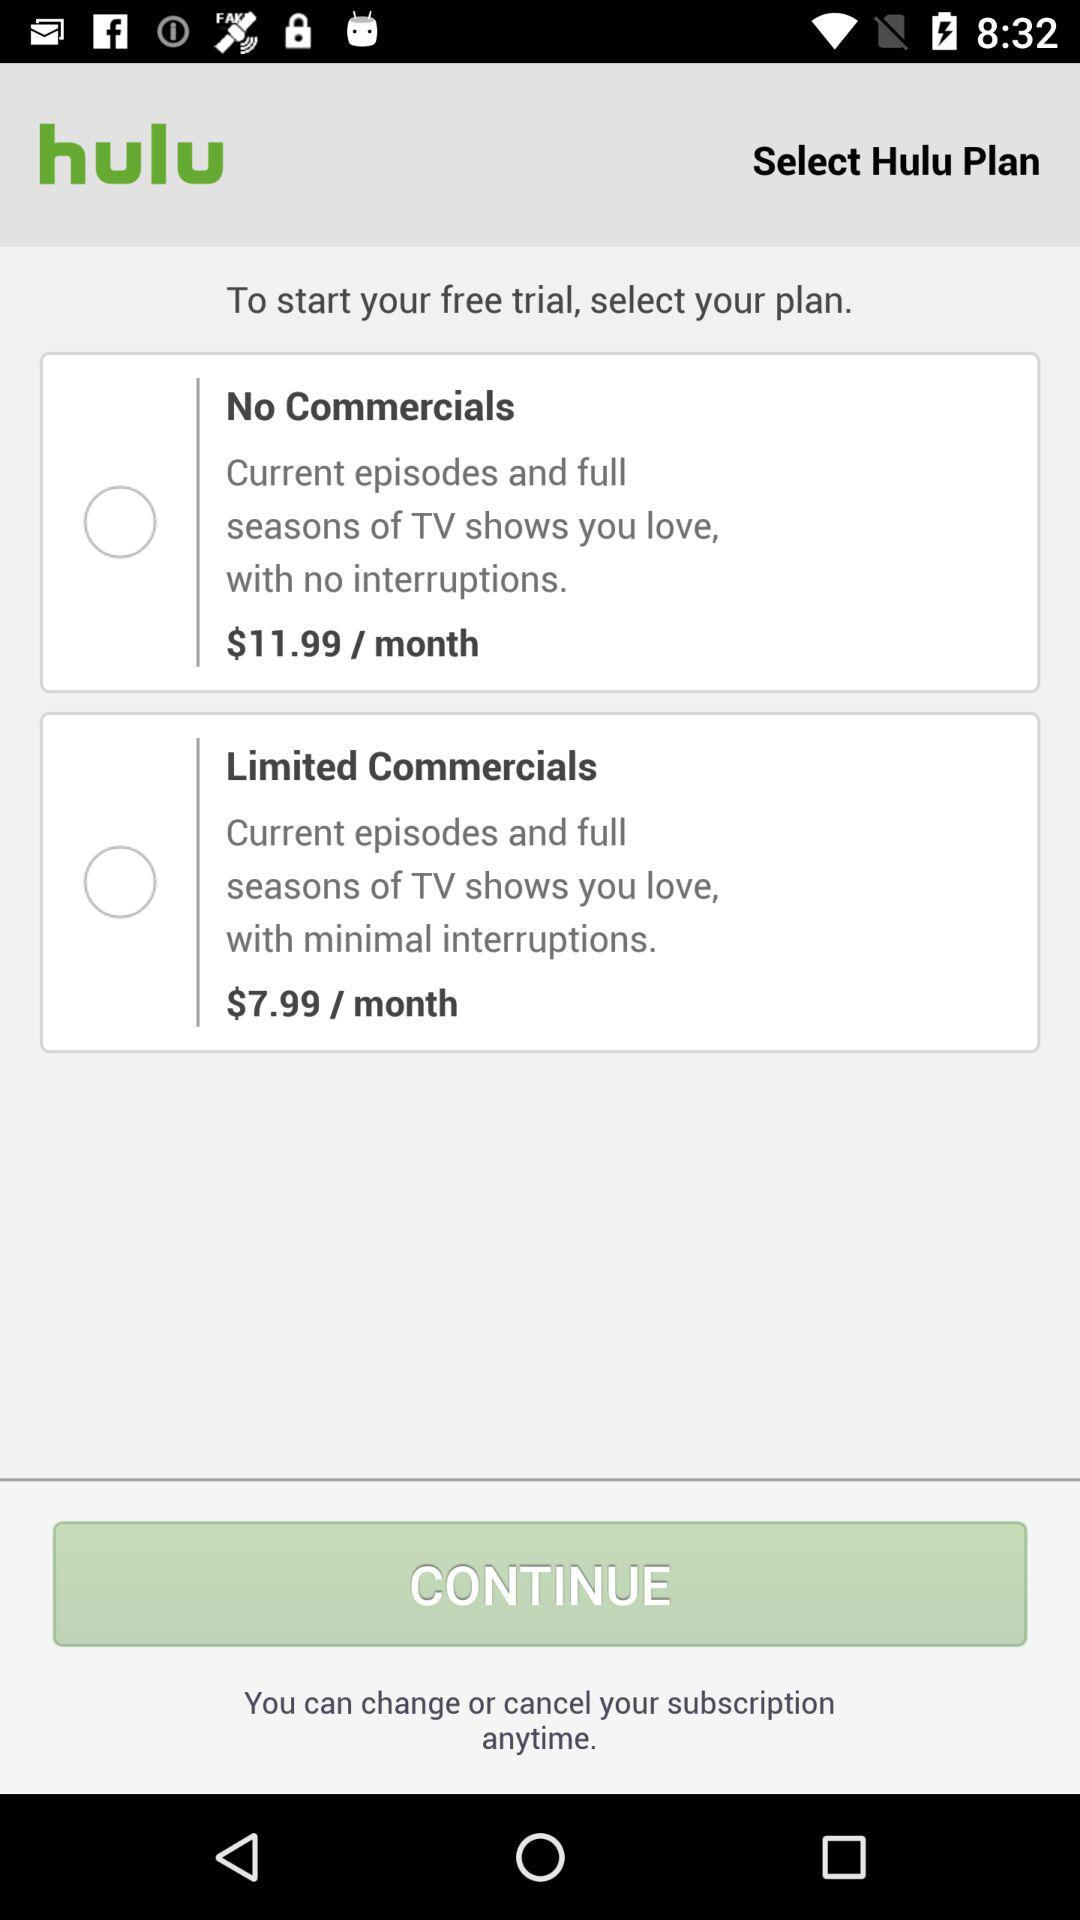What is the currency of price? The currency is the dollar. 